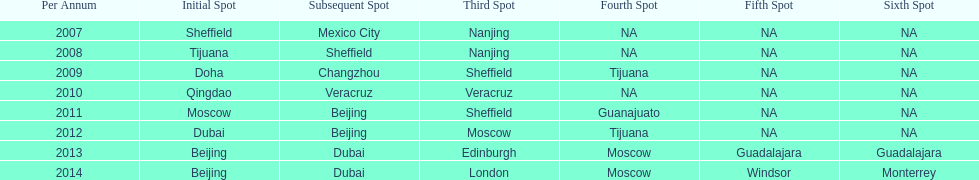In list of venues, how many years was beijing above moscow (1st venue is above 2nd venue, etc)? 3. 